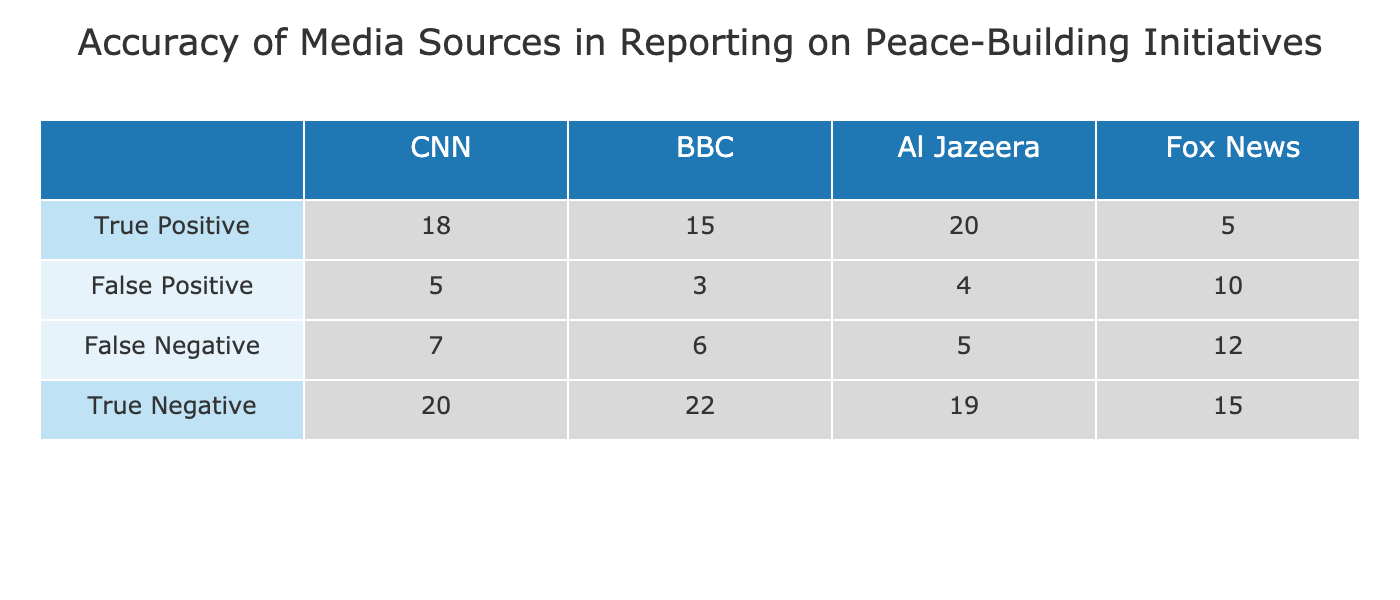What is the true positive count for CNN? The true positive count for CNN is found in the row labeled "True Positive" under the CNN column. According to the table, this value is 18.
Answer: 18 What media source has the highest number of false negatives? To find the highest number of false negatives, we can compare the values in the "False Negative" row across all media sources. The values are 7 for CNN, 6 for BBC, 5 for Al Jazeera, and 12 for Fox News. The highest value is 12 from Fox News.
Answer: Fox News What is the total number of true positives across all media sources? To get the total number of true positives, we sum the values in the "True Positive" row: 18 (CNN) + 15 (BBC) + 20 (Al Jazeera) + 5 (Fox News) = 58.
Answer: 58 Is the number of true positives for Al Jazeera greater than the sum of false positives for CNN and BBC? First, we find the true positive count for Al Jazeera, which is 20. Next, we sum the false positives for CNN (5) and BBC (3), giving us 5 + 3 = 8. Since 20 is greater than 8, the statement is true.
Answer: Yes What is the average number of true negatives for all media sources? To calculate the average of true negatives, we need the total number of true negatives from the "True Negative" row: 20 (CNN) + 22 (BBC) + 19 (Al Jazeera) + 15 (Fox News) = 76. There are 4 media sources, so we divide 76 by 4, yielding an average of 19.
Answer: 19 Which media source has the lowest accuracy in reporting peace-building initiatives, and what is that accuracy? First, we need to identify the accuracy for each media source, which can be calculated using the formula: (True Positives + True Negatives) / (Total Predictions). For each media source: CNN = (18 + 20) / (18 + 20 + 5 + 7) = 38/50 = 0.76, BBC = (15 + 22) / (15 + 22 + 3 + 6) = 37/46 ≈ 0.804, Al Jazeera = (20 + 19) / (20 + 19 + 4 + 5) = 39/48 ≈ 0.8125, Fox News = (5 + 15) / (5 + 15 + 10 + 12) = 20/42 ≈ 0.476. Fox News has the lowest accuracy of approximately 0.476.
Answer: Fox News, 0.476 What is the sum of true and false positives for BBC? To find this, we add the true positives (15) and false positives (3) for BBC. The sum is 15 + 3 = 18.
Answer: 18 Is the sum of true negatives for Al Jazeera less than the true negatives for CNN? The true negatives for Al Jazeera is 19, while for CNN it is 20. Since 19 is less than 20, the answer is true.
Answer: Yes 